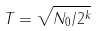Convert formula to latex. <formula><loc_0><loc_0><loc_500><loc_500>T = \sqrt { N _ { 0 } / 2 ^ { k } }</formula> 